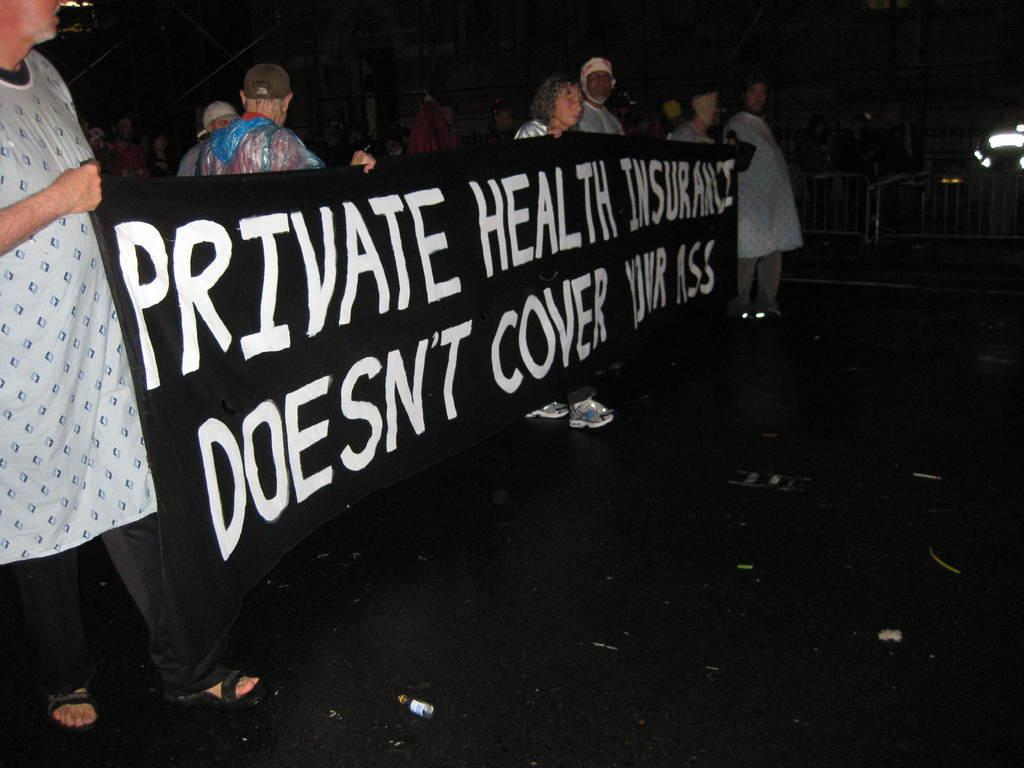What is happening in the image involving the group of people? There is a group of people in the image, and they are holding a banner. What can be seen in the background of the image? The background of the image is dark. What is the purpose of the fence in the image? The purpose of the fence in the image is not specified, but it is a visible object. What type of question is the donkey asking in the image? There is no donkey present in the image, and therefore no questions are being asked by a donkey. 